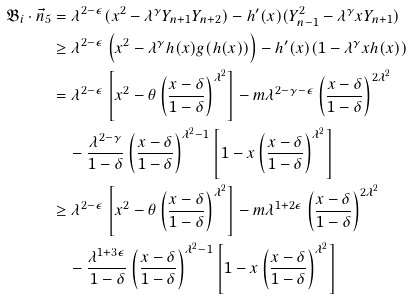Convert formula to latex. <formula><loc_0><loc_0><loc_500><loc_500>\mathfrak { B } _ { i } \cdot \vec { n } _ { 5 } & = \lambda ^ { 2 - \epsilon } ( x ^ { 2 } - \lambda ^ { \gamma } Y _ { n + 1 } Y _ { n + 2 } ) - h ^ { \prime } ( x ) ( Y _ { n - 1 } ^ { 2 } - \lambda ^ { \gamma } x Y _ { n + 1 } ) \\ & \geq \lambda ^ { 2 - \epsilon } \left ( x ^ { 2 } - \lambda ^ { \gamma } h ( x ) g ( h ( x ) ) \right ) - h ^ { \prime } ( x ) ( 1 - \lambda ^ { \gamma } x h ( x ) ) \\ & = \lambda ^ { 2 - \epsilon } \left [ x ^ { 2 } - \theta \left ( \frac { x - \delta } { 1 - \delta } \right ) ^ { \lambda ^ { 2 } } \right ] - m \lambda ^ { 2 - \gamma - \epsilon } \left ( \frac { x - \delta } { 1 - \delta } \right ) ^ { 2 \lambda ^ { 2 } } \\ & \quad - \frac { \lambda ^ { 2 - \gamma } } { 1 - \delta } \left ( \frac { x - \delta } { 1 - \delta } \right ) ^ { \lambda ^ { 2 } - 1 } \left [ 1 - x \left ( \frac { x - \delta } { 1 - \delta } \right ) ^ { \lambda ^ { 2 } } \right ] \\ & \geq \lambda ^ { 2 - \epsilon } \left [ x ^ { 2 } - \theta \left ( \frac { x - \delta } { 1 - \delta } \right ) ^ { \lambda ^ { 2 } } \right ] - m \lambda ^ { 1 + 2 \epsilon } \left ( \frac { x - \delta } { 1 - \delta } \right ) ^ { 2 \lambda ^ { 2 } } \\ & \quad - \frac { \lambda ^ { 1 + 3 \epsilon } } { 1 - \delta } \left ( \frac { x - \delta } { 1 - \delta } \right ) ^ { \lambda ^ { 2 } - 1 } \left [ 1 - x \left ( \frac { x - \delta } { 1 - \delta } \right ) ^ { \lambda ^ { 2 } } \right ] \\</formula> 